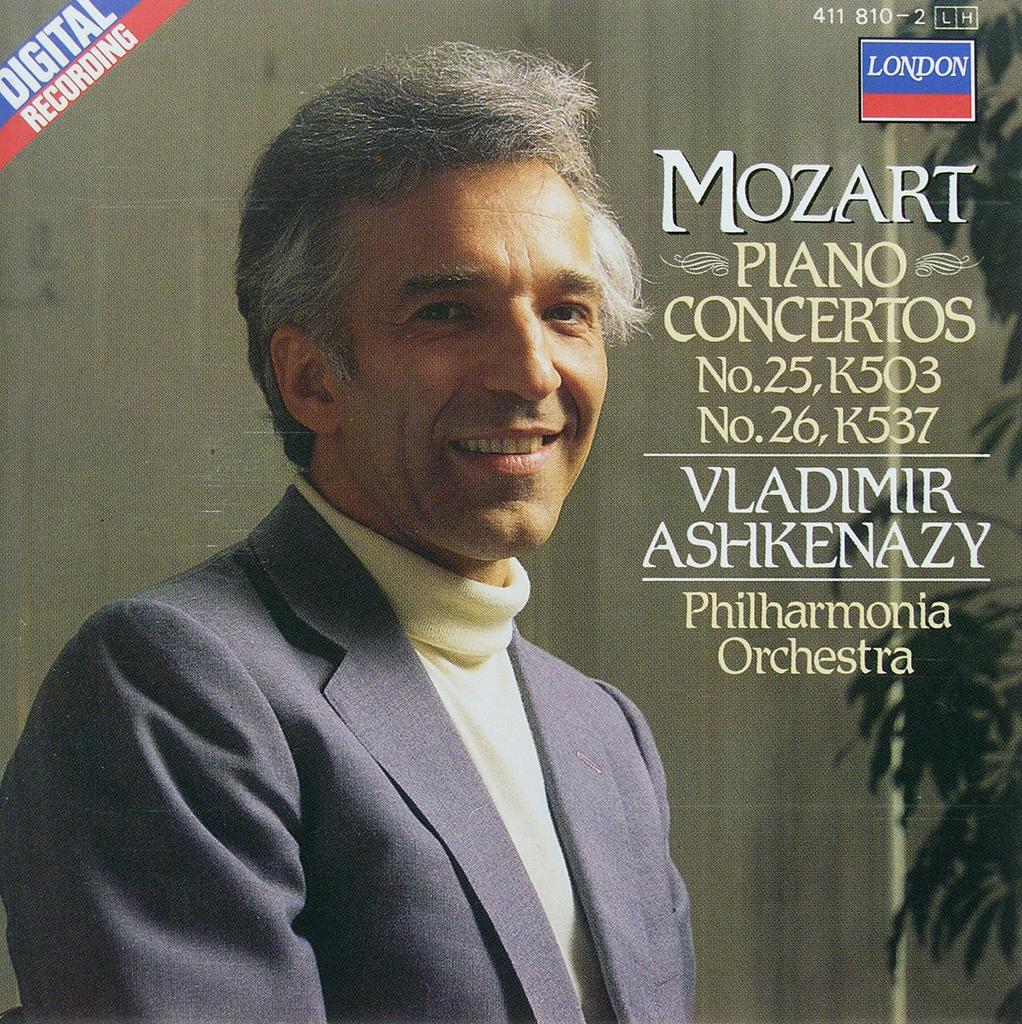<image>
Relay a brief, clear account of the picture shown. a photo of a man on for a music album that says Digital Recording on it 